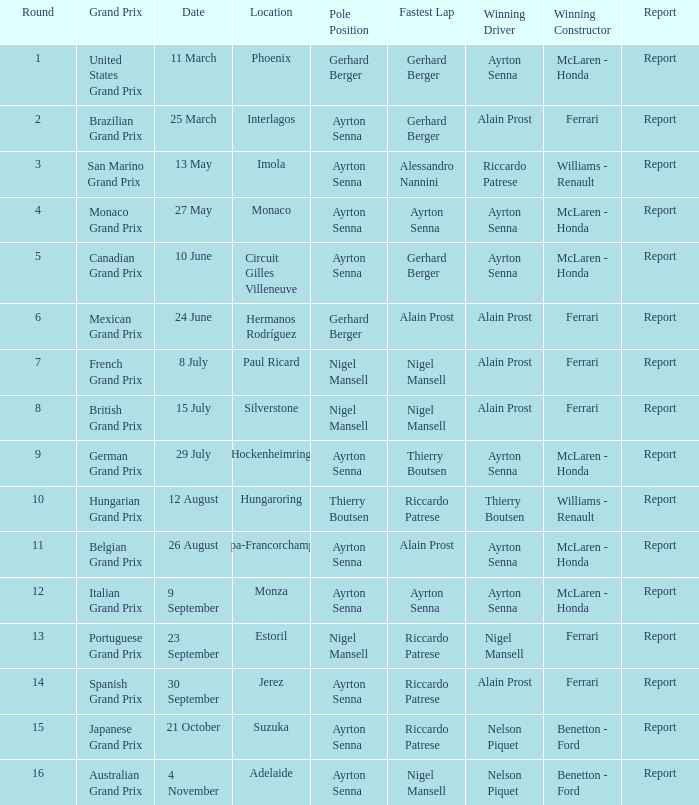On which date did ayrton senna drive in monza? 9 September. 